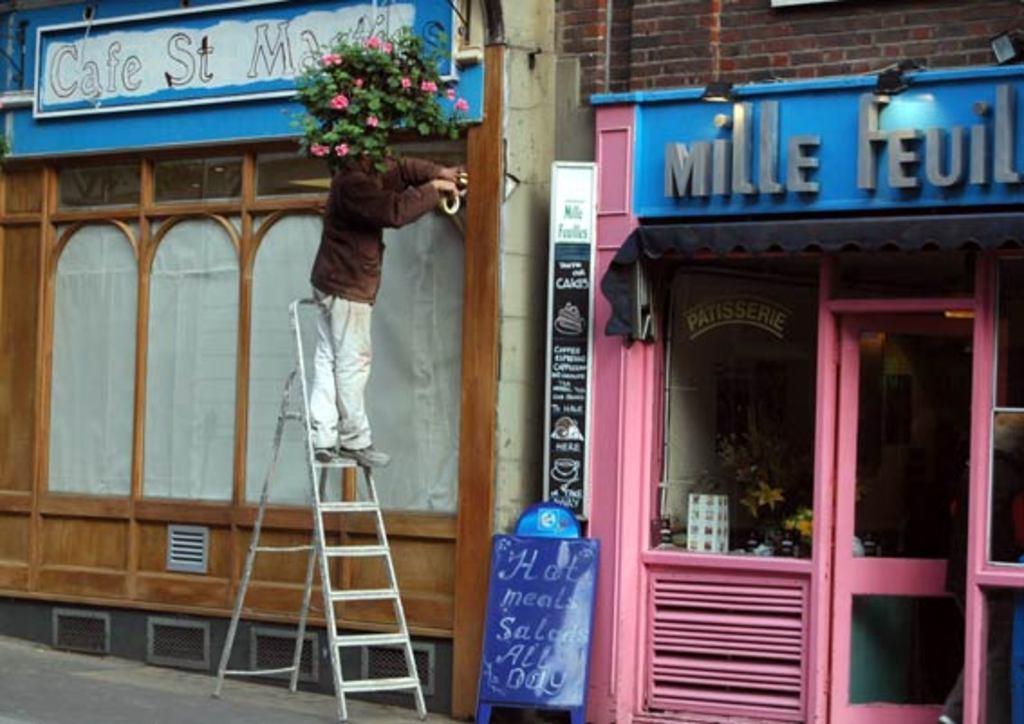Could you give a brief overview of what you see in this image? In the middle of the image there is a ladder, on the ladder a man is standing. Behind him there are some buildings and there is a plant and flowers. Bottom of the image there is a banner. 